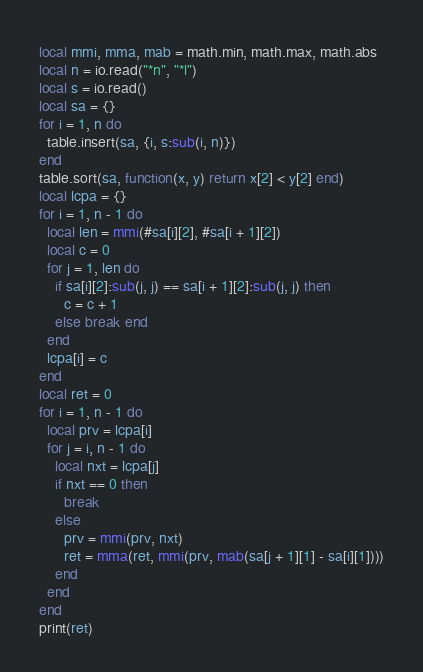<code> <loc_0><loc_0><loc_500><loc_500><_Lua_>local mmi, mma, mab = math.min, math.max, math.abs
local n = io.read("*n", "*l")
local s = io.read()
local sa = {}
for i = 1, n do
  table.insert(sa, {i, s:sub(i, n)})
end
table.sort(sa, function(x, y) return x[2] < y[2] end)
local lcpa = {}
for i = 1, n - 1 do
  local len = mmi(#sa[i][2], #sa[i + 1][2])
  local c = 0
  for j = 1, len do
    if sa[i][2]:sub(j, j) == sa[i + 1][2]:sub(j, j) then
      c = c + 1
    else break end
  end
  lcpa[i] = c
end
local ret = 0
for i = 1, n - 1 do
  local prv = lcpa[i]
  for j = i, n - 1 do
    local nxt = lcpa[j]
    if nxt == 0 then
      break
    else
      prv = mmi(prv, nxt)
      ret = mma(ret, mmi(prv, mab(sa[j + 1][1] - sa[i][1])))
    end
  end
end
print(ret)
</code> 